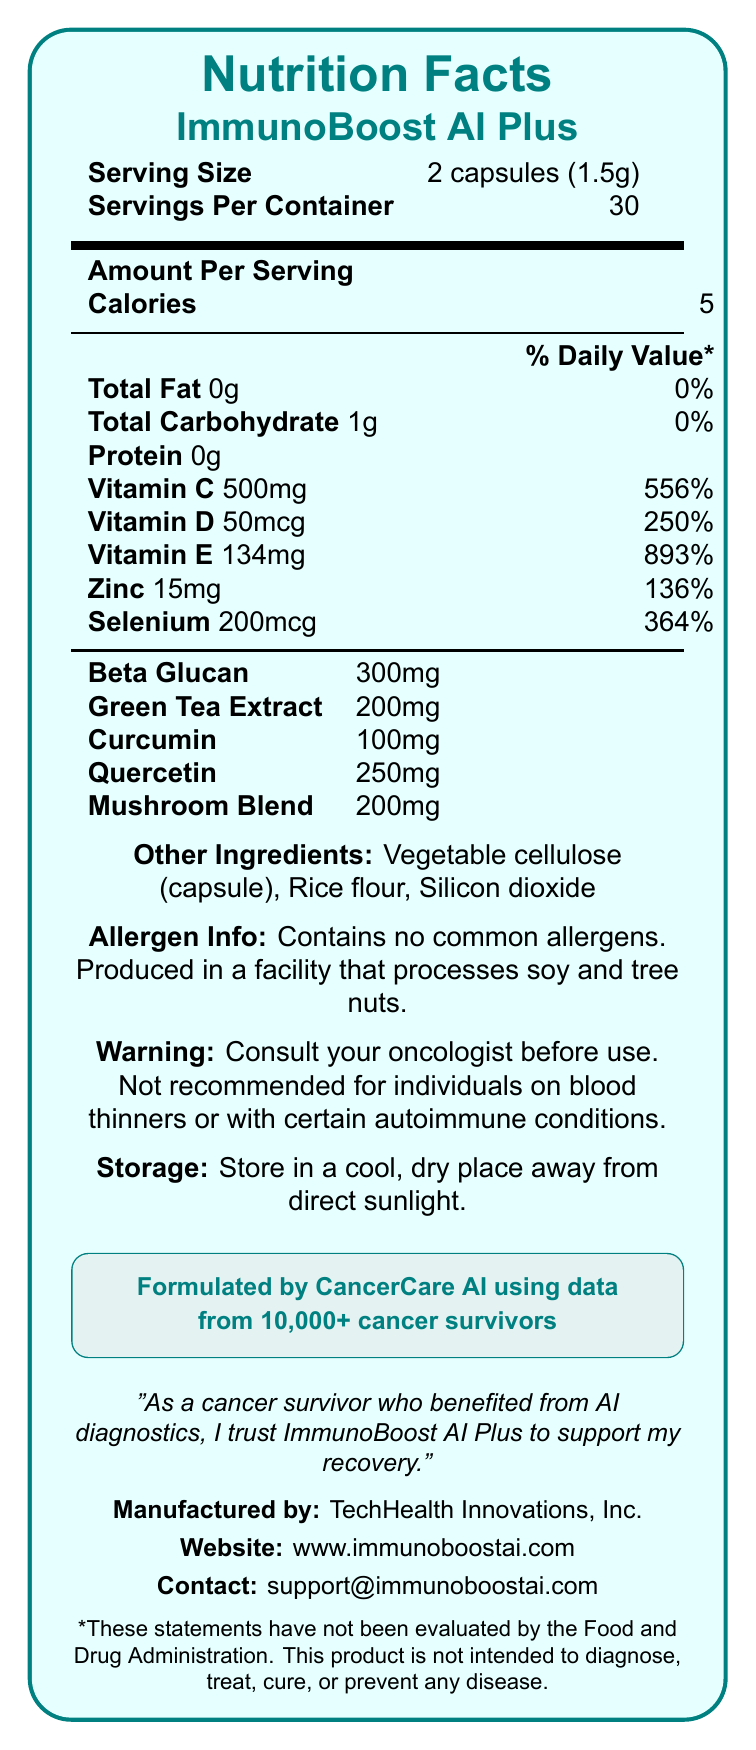who manufactures ImmunoBoost AI Plus? According to the document, ImmunoBoost AI Plus is manufactured by TechHealth Innovations, Inc.
Answer: TechHealth Innovations, Inc. what is the serving size of ImmunoBoost AI Plus? The serving size as stated on the document is 2 capsules, which amounts to 1.5 grams.
Answer: 2 capsules (1.5g) how many servings are there per container? The document specifies that there are 30 servings per container.
Answer: 30 servings how many calories are there per serving? The document indicates there are 5 calories per serving.
Answer: 5 calories what is the daily value percentage of vitamin C per serving? The document lists the daily value percentage for vitamin C as 556%.
Answer: 556% what are the colors used in the document? A. Red and white B. Blue and yellow C. Green and light green D. Purple and grey The document uses shades of green and light green for the boxes and text highlights.
Answer: C. Green and light green which of the following ingredients is present in the highest amount? A. Curcumin B. Beta Glucan C. Quercetin D. Green Tea Extract Beta Glucan is present in the highest amount, with 300mg per serving, according to the document.
Answer: B. Beta Glucan is the product suitable for individuals on blood thinners? The document warns that the product is not recommended for individuals on blood thinners.
Answer: No summarize the information provided in the document The document covers comprehensive nutritional and supplementary details relevant to cancer survivors, including the efficacy, formulation background, and critical usage information.
Answer: The document is a Nutrition Facts Label for ImmunoBoost AI Plus, an immune-boosting supplement for cancer survivors formulated using data from over 10,000 cancer survivors. It includes nutritional information, ingredient list, allergen info, warnings, and storage instructions. It highlights the vitamin, mineral, and herbal ingredient content, and provides manufacturer details along with a testimonial and FDA disclaimer. what is the email contact for support? The document lists the contact email for support as support@immunoboostai.com.
Answer: support@immunoboostai.com what is the main ingredient providing the highest percentage of daily value? The document shows Vitamin E providing 893% of the daily value, which is the highest among listed nutrients.
Answer: Vitamin E does the product contain common allergens? The document specifically states that the product contains no common allergens.
Answer: No what is the basis for the formulation of ImmunoBoost AI Plus? The document mentions the product is formulated by CancerCare AI using data from over 10,000 cancer survivors.
Answer: Formulated by CancerCare AI using data from 10,000+ cancer survivors how is the user advised to store the product? The storage instruction advises keeping the product in a cool, dry place away from direct sunlight.
Answer: In a cool, dry place away from direct sunlight how much curcumin is present per serving? The document states that each serving contains 100mg of curcumin.
Answer: 100mg is the product FDA approved? The document includes an FDA disclaimer that the statements have not been evaluated by the Food and Drug Administration.
Answer: No 